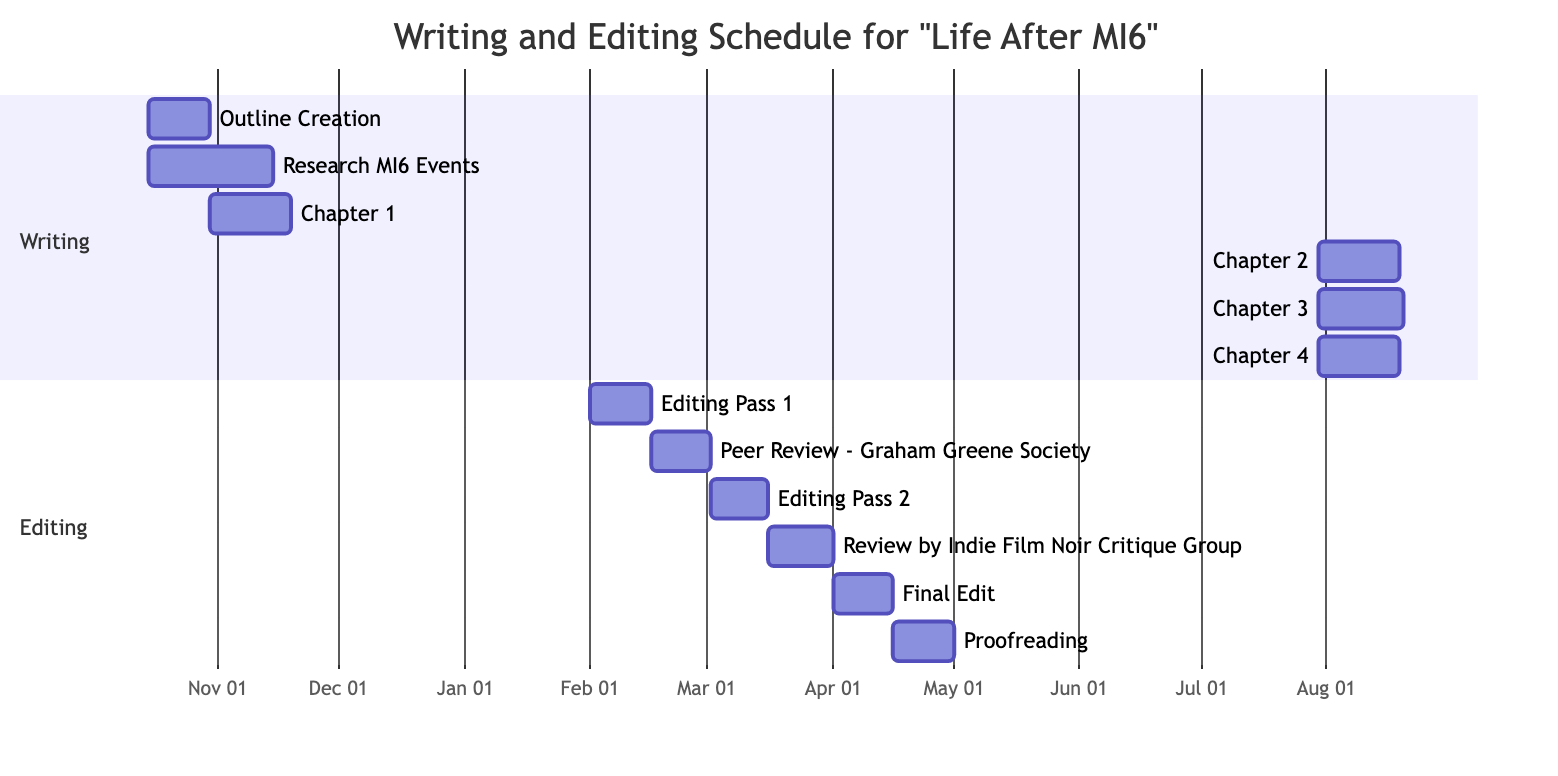What is the start date of Chapter 3? Chapter 3 begins on December 11, 2023, as indicated by the timeline in the diagram where it shows the start date for that task.
Answer: December 11, 2023 How many editing passes are there in the schedule? The diagram indicates there are three distinct editing passes: Editing Pass 1, Editing Pass 2, and Final Edit, totaling to three editing tasks.
Answer: Three What task follows the "Peer Review - Graham Greene Society"? The task that follows the "Peer Review - Graham Greene Society" is "Editing Pass 2," as it is shown right after in the workflow sequence of the diagram.
Answer: Editing Pass 2 When does the proofreading phase start? The proofreading task begins on April 16, 2024, as indicated by its start date in the diagram clearly showing this date aligned with its task bar.
Answer: April 16, 2024 Which chapter starts after "Chapter 1: Early Life and Recruitment"? The chapter that starts after "Chapter 1: Early Life and Recruitment" is "Chapter 2: Training and First Missions," based on the dependency path and timeline in the diagram.
Answer: Chapter 2: Training and First Missions What is the end date of the "Research MI6 Events"? The "Research MI6 Events" task ends on November 15, 2023, as directly shown in the end date within the timeline of the diagram.
Answer: November 15, 2023 How many days does "Chapter 4: Reflections on Espionage" last? "Chapter 4: Reflections on Espionage" lasts for 20 days, starting from January 1, 2024, and ending on January 20, 2024, making it a clear duration right from the task bar.
Answer: 20 days Which task has dependencies linked to "Editing Pass 1"? The task that has dependencies linked to "Editing Pass 1" is "Peer Review - Graham Greene Society," as illustrated in the task dependencies figure in the diagram.
Answer: Peer Review - Graham Greene Society What is the Gantt Chart primarily used to visualize? The Gantt Chart is primarily used to visualize the writing and editing schedule for the autobiography project, as indicated in the title of the diagram.
Answer: Writing and editing schedule 